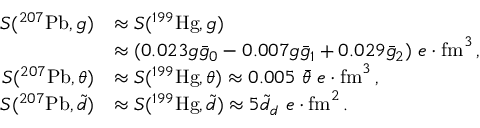Convert formula to latex. <formula><loc_0><loc_0><loc_500><loc_500>\begin{array} { r l } { S ( ^ { 2 0 7 } P b , g ) } & { \approx S ( ^ { 1 9 9 } H g , g ) } \\ & { \approx ( 0 . 0 2 3 g \bar { g } _ { 0 } - 0 . 0 0 7 g \bar { g } _ { 1 } + 0 . 0 2 9 \bar { g } _ { 2 } ) \ e \cdot f m ^ { 3 } \, , } \\ { S ( ^ { 2 0 7 } P b , \theta ) } & { \approx S ( ^ { 1 9 9 } H g , \theta ) \approx 0 . 0 0 5 \ \bar { \theta } \ e \cdot f m ^ { 3 } \, , } \\ { S ( ^ { 2 0 7 } P b , \tilde { d } ) } & { \approx S ( ^ { 1 9 9 } H g , \tilde { d } ) \approx 5 \tilde { d } _ { d } \ e \cdot f m ^ { 2 } \, . } \end{array}</formula> 